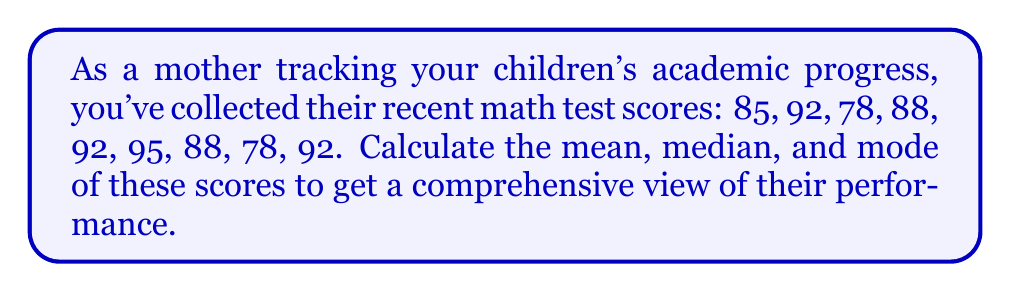Can you answer this question? Let's approach this step-by-step:

1. Mean:
   The mean is the average of all scores.
   
   $$ \text{Mean} = \frac{\text{Sum of all scores}}{\text{Number of scores}} $$
   
   First, add all the scores:
   $$ 85 + 92 + 78 + 88 + 92 + 95 + 88 + 78 + 92 = 788 $$
   
   Then divide by the number of scores (9):
   $$ \text{Mean} = \frac{788}{9} \approx 87.56 $$

2. Median:
   The median is the middle value when the scores are arranged in order.
   
   Arrange the scores in ascending order:
   $$ 78, 78, 85, 88, 88, 92, 92, 92, 95 $$
   
   With 9 scores, the 5th score is the median:
   $$ \text{Median} = 88 $$

3. Mode:
   The mode is the score that appears most frequently.
   
   Counting occurrences:
   78 appears 2 times
   85 appears 1 time
   88 appears 2 times
   92 appears 3 times
   95 appears 1 time
   
   $$ \text{Mode} = 92 $$
Answer: Mean: $87.56$
Median: $88$
Mode: $92$ 